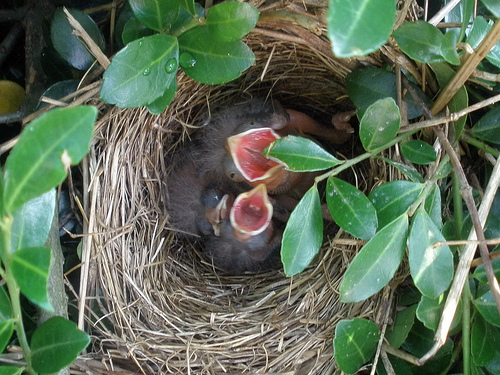What can you infer about the age of these birds? Given their size, lack of feathers, and open mouths, these birds are likely very young, possibly only a few days old. At this stage, they are dependent on their parents for warmth and food. 